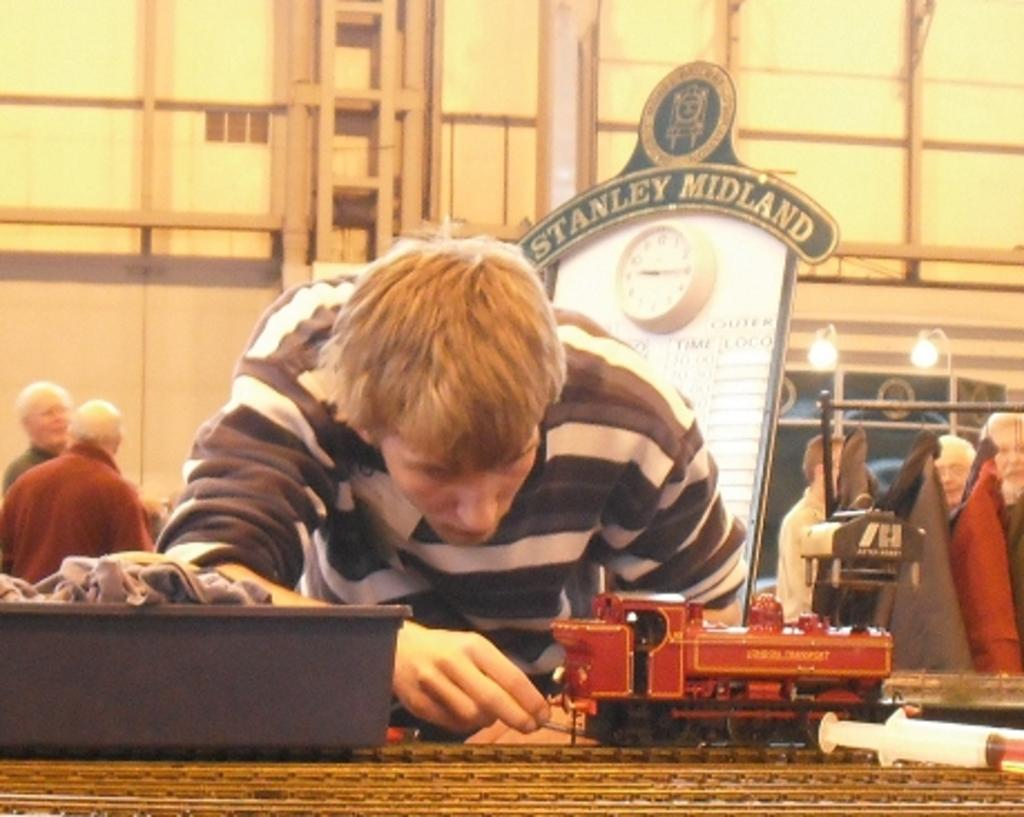Who is the main subject in the image? There is a boy in the image. What toy is the boy interacting with? There is a toy train in the image. What can be seen in the background of the image? There is a board and people standing in the background of the image. What type of structure is visible in the image? There is a wall visible in the image. What type of pollution can be seen in the image? There is no pollution visible in the image. What is the weather like in the image? The provided facts do not give any information about the weather in the image. 